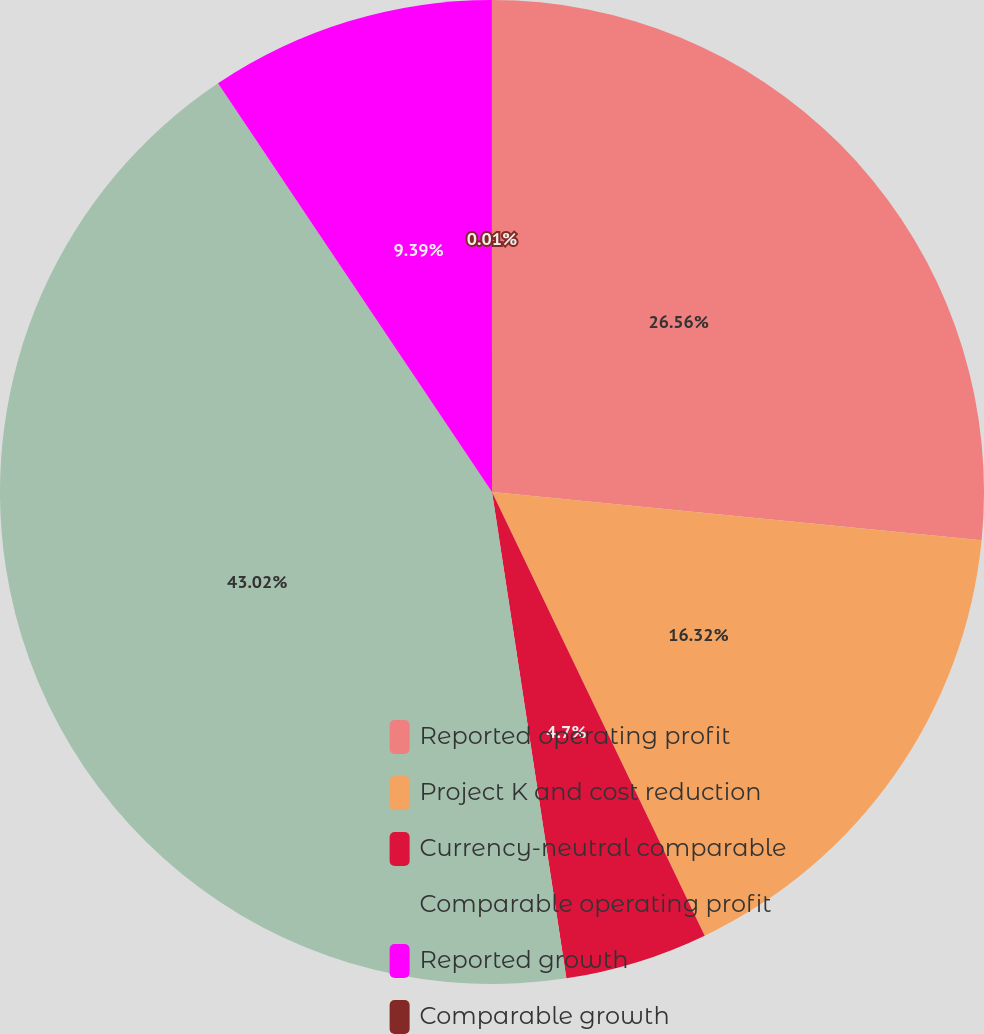Convert chart to OTSL. <chart><loc_0><loc_0><loc_500><loc_500><pie_chart><fcel>Reported operating profit<fcel>Project K and cost reduction<fcel>Currency-neutral comparable<fcel>Comparable operating profit<fcel>Reported growth<fcel>Comparable growth<nl><fcel>26.56%<fcel>16.32%<fcel>4.7%<fcel>43.01%<fcel>9.39%<fcel>0.01%<nl></chart> 